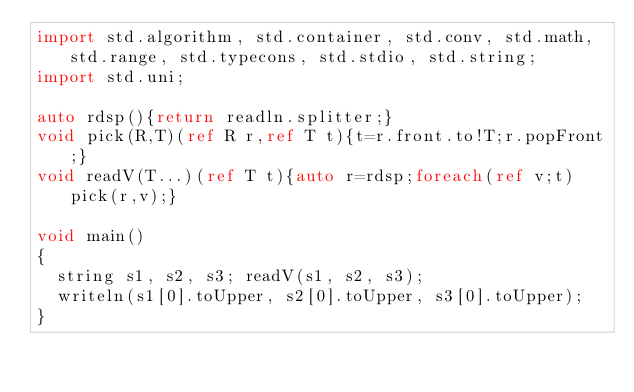Convert code to text. <code><loc_0><loc_0><loc_500><loc_500><_D_>import std.algorithm, std.container, std.conv, std.math, std.range, std.typecons, std.stdio, std.string;
import std.uni;

auto rdsp(){return readln.splitter;}
void pick(R,T)(ref R r,ref T t){t=r.front.to!T;r.popFront;}
void readV(T...)(ref T t){auto r=rdsp;foreach(ref v;t)pick(r,v);}

void main()
{
  string s1, s2, s3; readV(s1, s2, s3);
  writeln(s1[0].toUpper, s2[0].toUpper, s3[0].toUpper);
}
</code> 